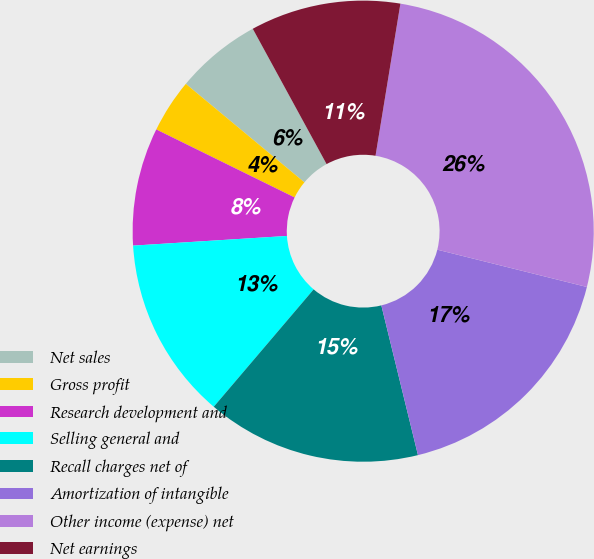Convert chart. <chart><loc_0><loc_0><loc_500><loc_500><pie_chart><fcel>Net sales<fcel>Gross profit<fcel>Research development and<fcel>Selling general and<fcel>Recall charges net of<fcel>Amortization of intangible<fcel>Other income (expense) net<fcel>Net earnings<nl><fcel>6.02%<fcel>3.76%<fcel>8.27%<fcel>12.78%<fcel>15.04%<fcel>17.29%<fcel>26.31%<fcel>10.53%<nl></chart> 